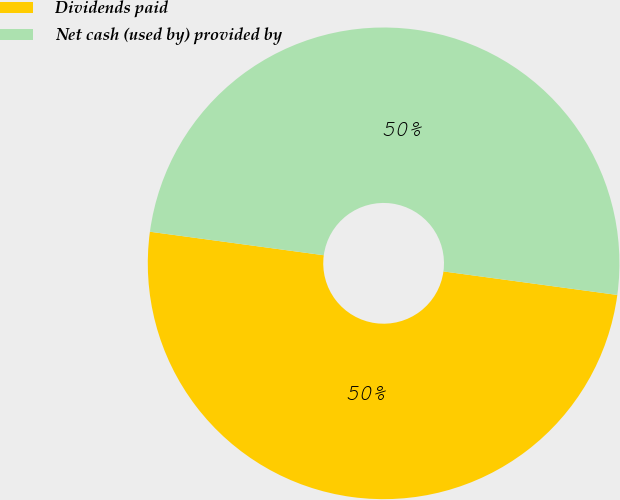<chart> <loc_0><loc_0><loc_500><loc_500><pie_chart><fcel>Dividends paid<fcel>Net cash (used by) provided by<nl><fcel>50.0%<fcel>50.0%<nl></chart> 